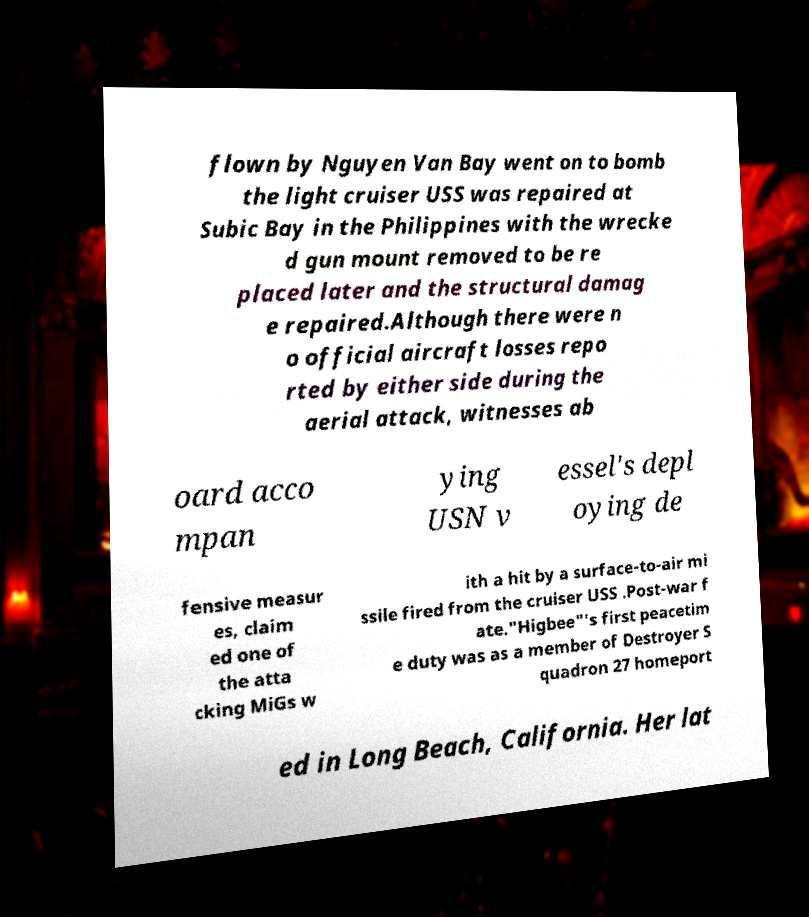Can you read and provide the text displayed in the image?This photo seems to have some interesting text. Can you extract and type it out for me? flown by Nguyen Van Bay went on to bomb the light cruiser USS was repaired at Subic Bay in the Philippines with the wrecke d gun mount removed to be re placed later and the structural damag e repaired.Although there were n o official aircraft losses repo rted by either side during the aerial attack, witnesses ab oard acco mpan ying USN v essel's depl oying de fensive measur es, claim ed one of the atta cking MiGs w ith a hit by a surface-to-air mi ssile fired from the cruiser USS .Post-war f ate."Higbee"'s first peacetim e duty was as a member of Destroyer S quadron 27 homeport ed in Long Beach, California. Her lat 